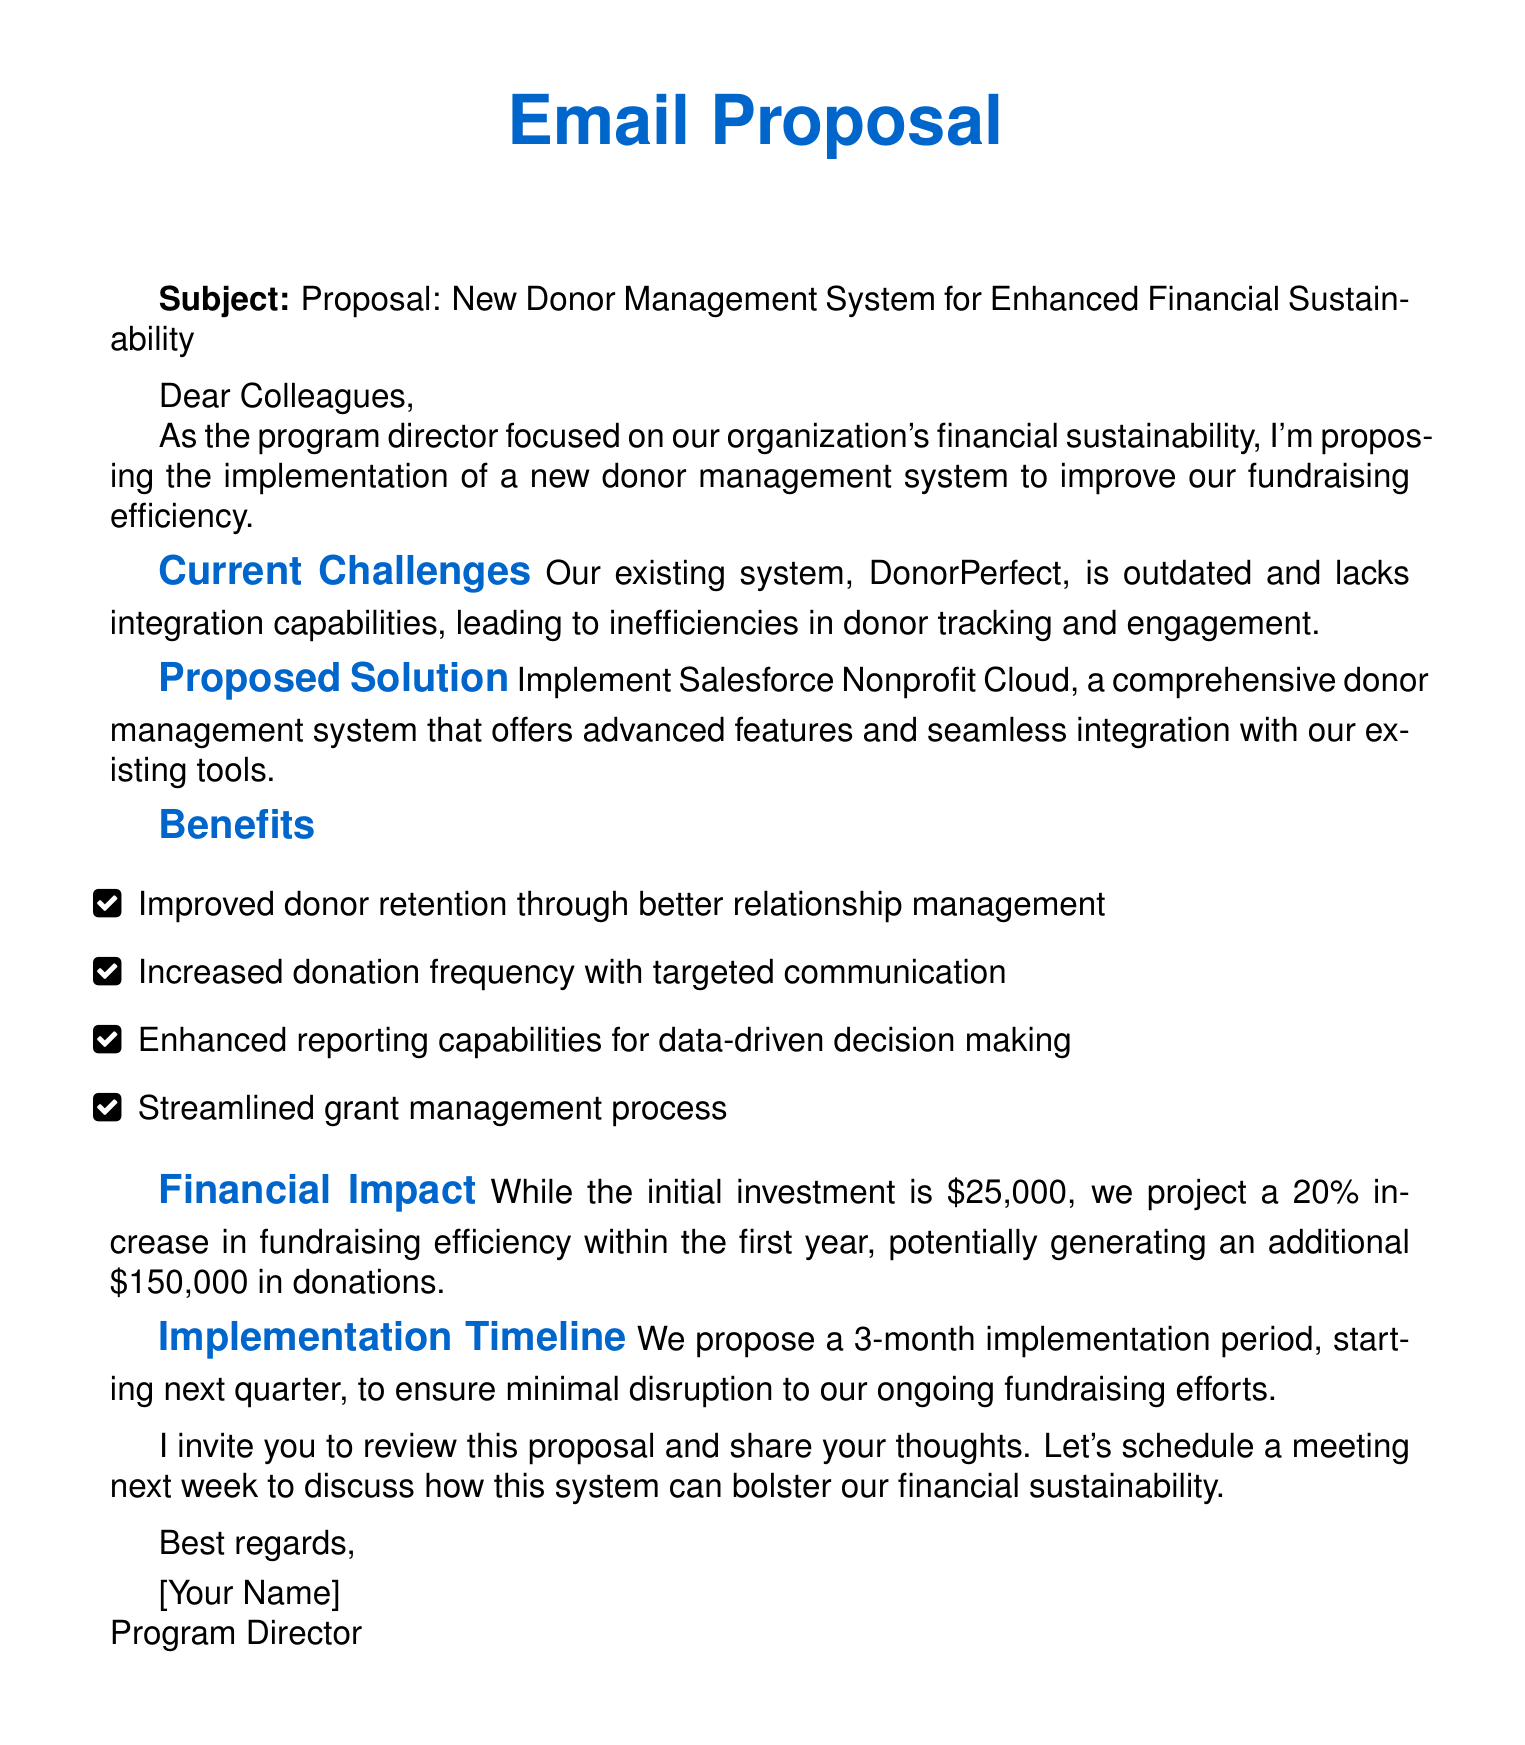What is the total investment for the new system? The total investment for the new system is mentioned in the financial impact section of the document, which states that the initial investment is $25,000.
Answer: $25,000 What system is being proposed? The proposed system is mentioned in the proposed solution section, which specifies Salesforce Nonprofit Cloud as the donor management system.
Answer: Salesforce Nonprofit Cloud How much increase in fundraising efficiency is projected? The financial impact section indicates a projected increase of 20% in fundraising efficiency within the first year.
Answer: 20% What is the potential additional revenue from the new system? The document states that the potential additional revenue from the new system is $150,000.
Answer: $150,000 What is the implementation period proposed? The implementation timeline section mentions a 3-month implementation period proposed for the system.
Answer: 3 months What is the main focus of the program director? The introduction specifies that the program director’s main focus is on the organization's financial sustainability.
Answer: Financial sustainability What invitation is made to the colleagues? The call to action invites colleagues to review the proposal and share their thoughts, suggesting a meeting next week for further discussion.
Answer: Review this proposal and share your thoughts What are the benefits listed in the proposal? The benefits section lists advantages like improved donor retention, increased donation frequency, enhanced reporting capabilities, and streamlined grant management.
Answer: Improved donor retention, increased donation frequency, enhanced reporting capabilities, streamlined grant management 